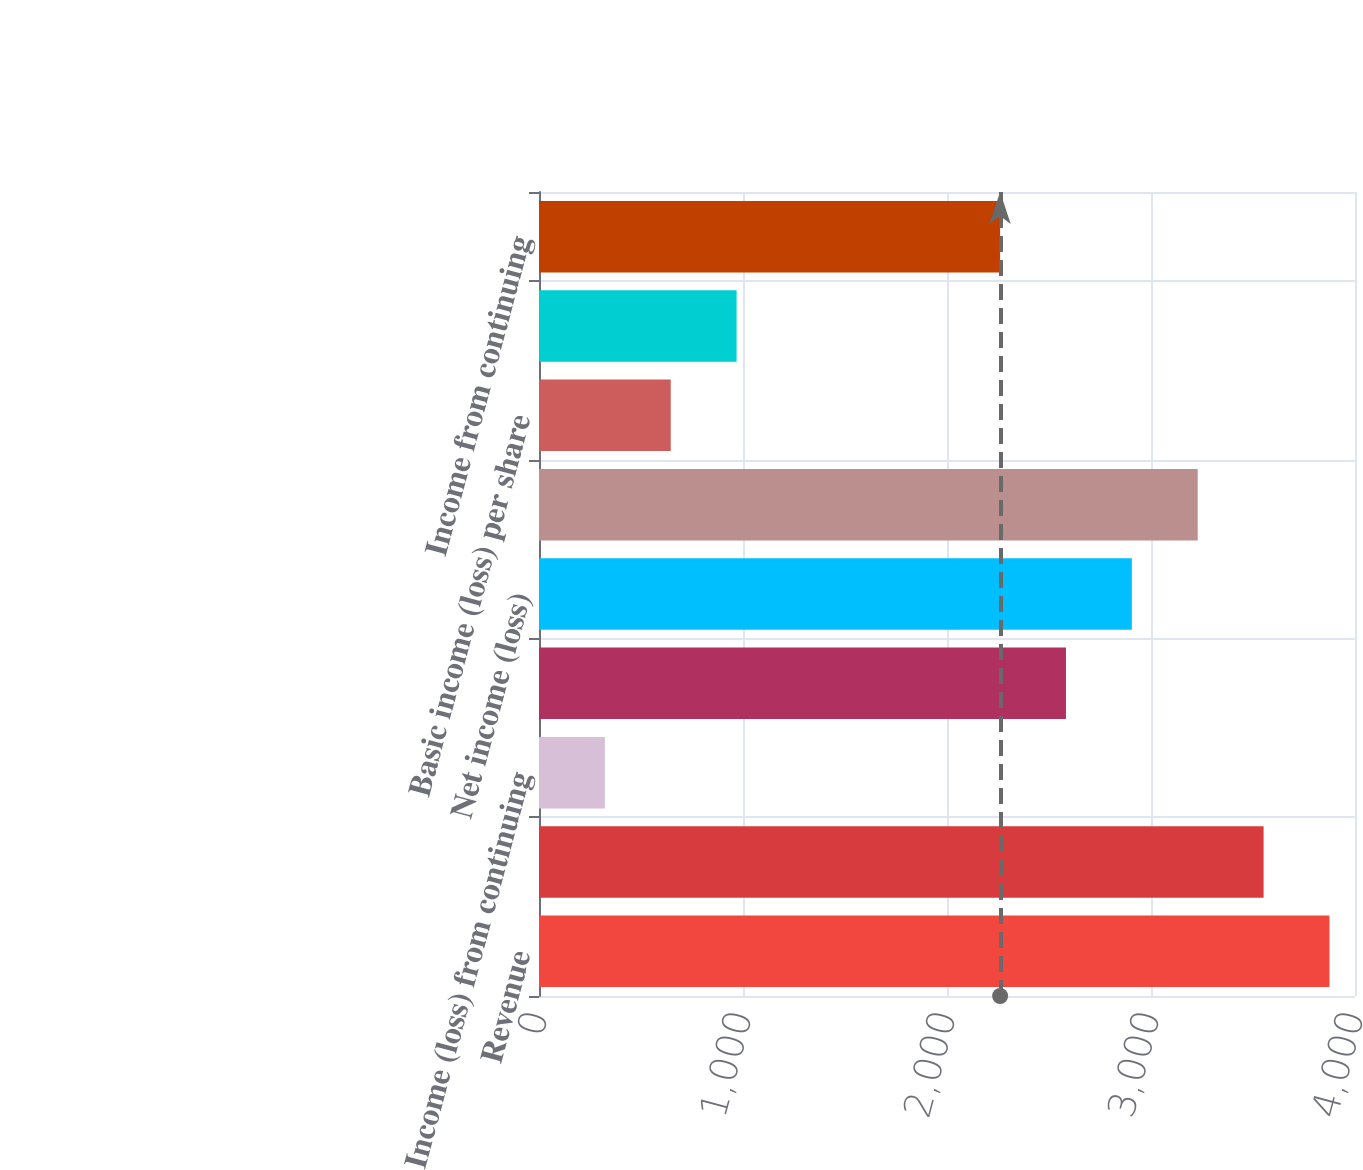<chart> <loc_0><loc_0><loc_500><loc_500><bar_chart><fcel>Revenue<fcel>Operating margin<fcel>Income (loss) from continuing<fcel>(Loss) from discontinued<fcel>Net income (loss)<fcel>Net income (loss) attributable<fcel>Basic income (loss) per share<fcel>Diluted income (loss) per<fcel>Income from continuing<nl><fcel>3874.81<fcel>3551.91<fcel>322.91<fcel>2583.21<fcel>2906.11<fcel>3229.01<fcel>645.81<fcel>968.71<fcel>2260.31<nl></chart> 